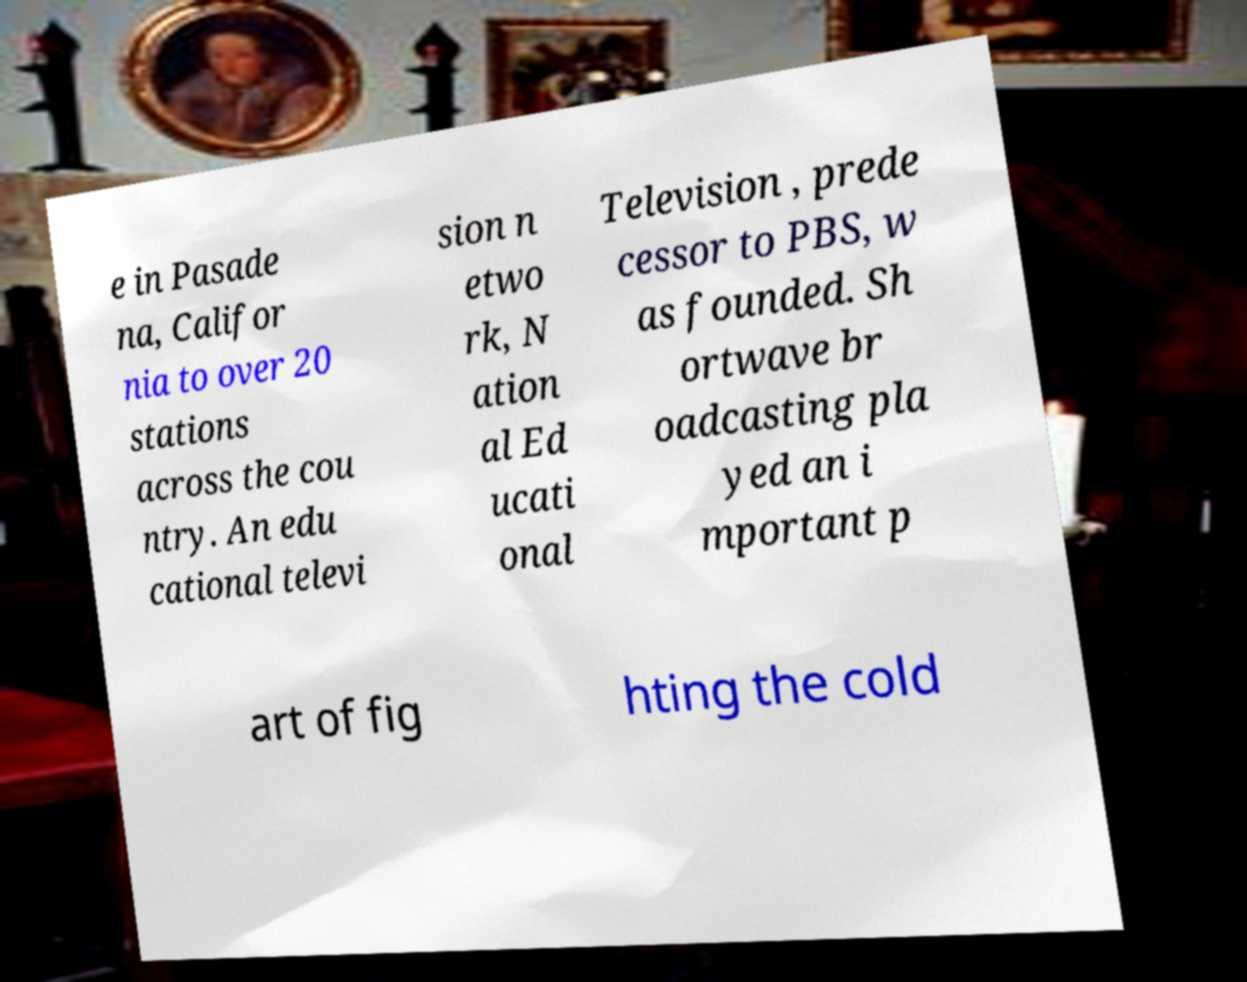Please read and relay the text visible in this image. What does it say? e in Pasade na, Califor nia to over 20 stations across the cou ntry. An edu cational televi sion n etwo rk, N ation al Ed ucati onal Television , prede cessor to PBS, w as founded. Sh ortwave br oadcasting pla yed an i mportant p art of fig hting the cold 